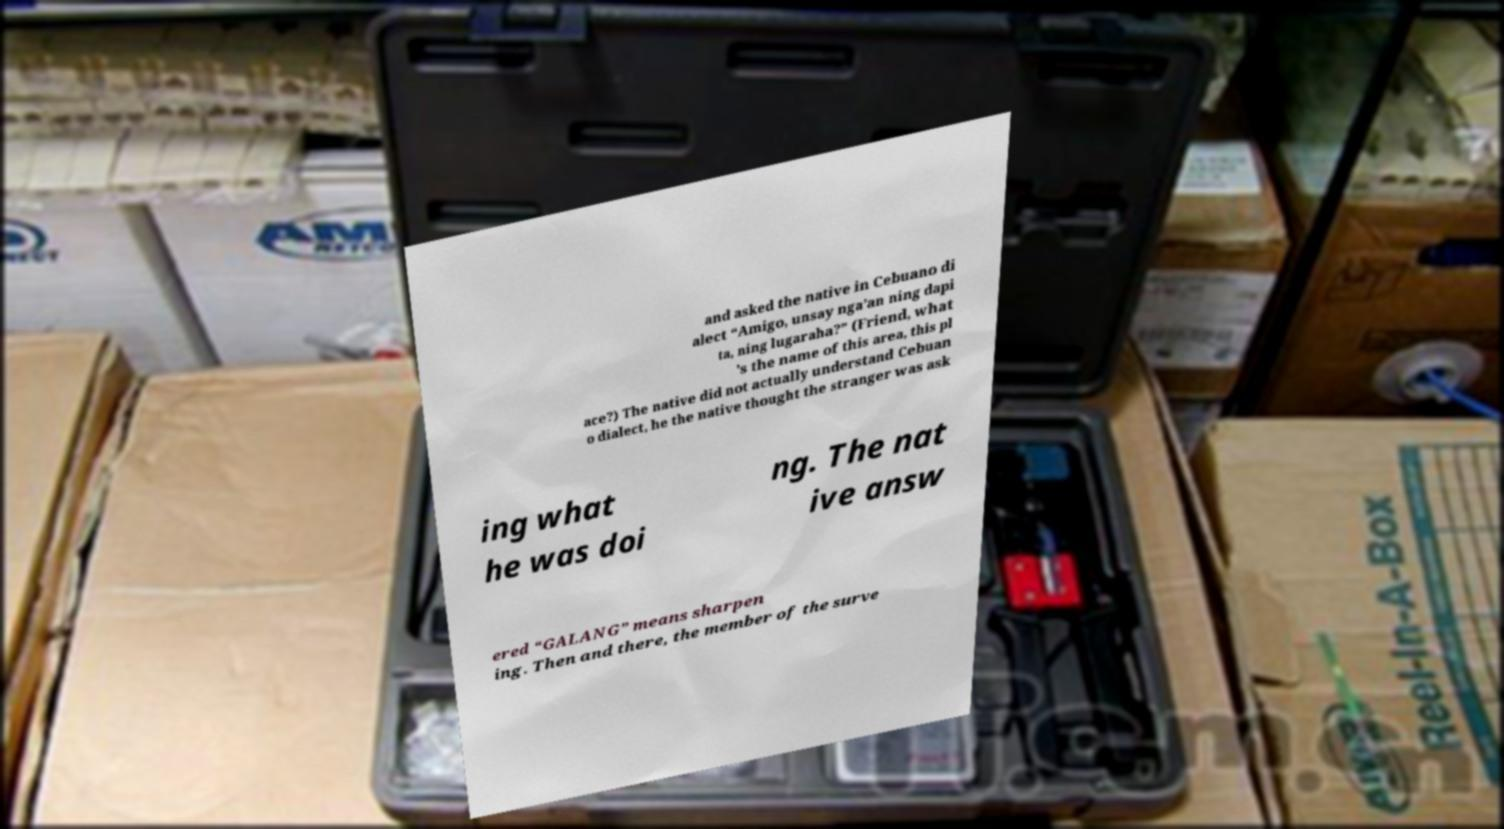Could you assist in decoding the text presented in this image and type it out clearly? and asked the native in Cebuano di alect “Amigo, unsay nga’an ning dapi ta, ning lugaraha?” (Friend, what 's the name of this area, this pl ace?) The native did not actually understand Cebuan o dialect, he the native thought the stranger was ask ing what he was doi ng. The nat ive answ ered “GALANG” means sharpen ing. Then and there, the member of the surve 